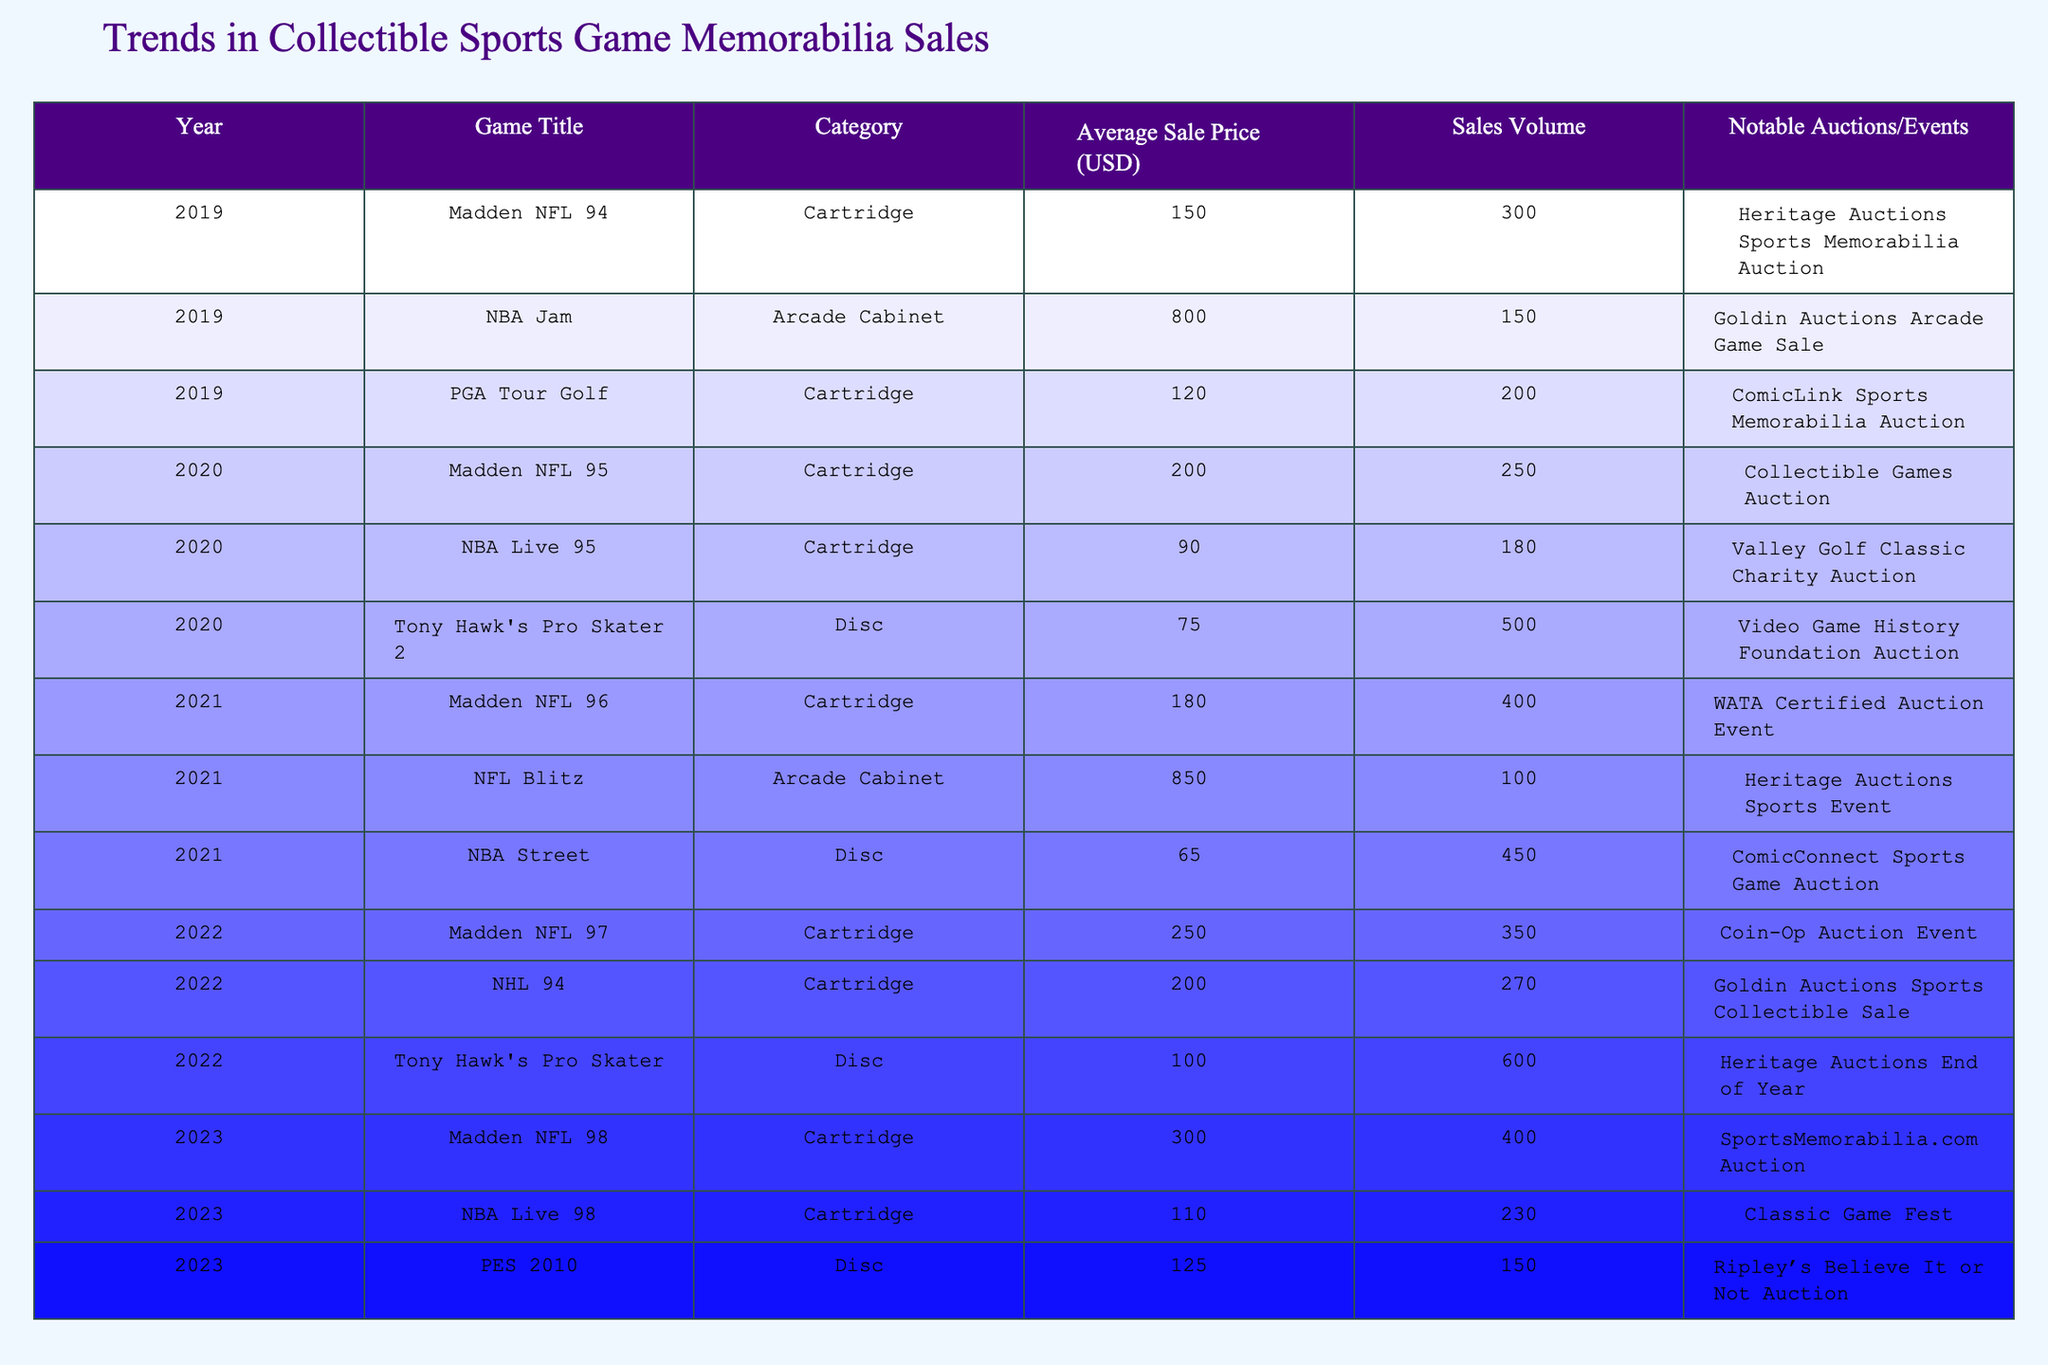What was the average sale price of Madden NFL games over the five years? The Madden NFL games listed are from 2019 (150), 2020 (200), 2021 (180), 2022 (250), and 2023 (300). Adding these prices gives us a total of 1080. There are 5 games, so the average price is 1080/5 = 216.
Answer: 216 Which sports game had the highest average sale price in 2021? The games listed for 2021 are Madden NFL 96 (180), NFL Blitz (850), and NBA Street (65). The highest price among these is NFL Blitz at 850.
Answer: 850 How many total sales were recorded for NBA Jam across the years? The data shows NBA Jam was sold in 2019 with a sales volume of 150. There are no other records for NBA Jam in other years, so the total sales remain 150.
Answer: 150 Is the average sale price of Tony Hawk's Pro Skater 2 higher than that of Madden NFL 95? The average sale price for Tony Hawk's Pro Skater 2 is 75, while Madden NFL 95 is 200. Comparing these two, 75 is less than 200, so the statement is false.
Answer: No What is the total sales volume for cartridges across all years? The cartridge games and their sales volumes are: Madden NFL 94 (300), PGA Tour Golf (200), Madden NFL 95 (250), Madden NFL 96 (400), Madden NFL 97 (350), Madden NFL 98 (400), NBA Live 95 (180), NBA Live 98 (230), NHL 94 (270). Summing these gives 300 + 200 + 250 + 400 + 350 + 400 + 180 + 230 + 270 = 2580.
Answer: 2580 How many notable auctions/events were held for sports game categories with cartridges? The entries for cartridges include Madden NFL 94, PGA Tour Golf, Madden NFL 95, Madden NFL 96, Madden NFL 97, and Madden NFL 98, totaling 6 notable auctions/events.
Answer: 6 Which category had the lowest total sales volume in 2020? In 2020, the categories were Cartridge (Madden NFL 95 with 250 and NBA Live 95 with 180) and Disc (Tony Hawk's Pro Skater 2 with 500). The lowest sales volume for cartridges adds up to 430 (250 + 180), while disc adds to 500. Therefore, the lowest is the cartridge category.
Answer: Cartridge 